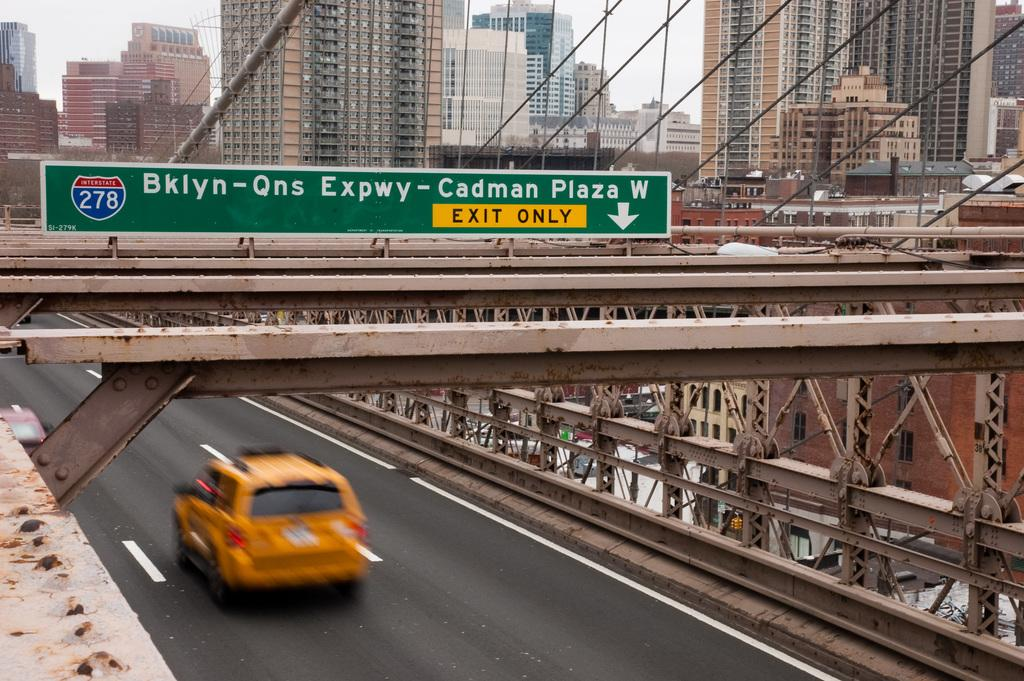<image>
Give a short and clear explanation of the subsequent image. Highway sign that says that the Exit is pointed that way. 